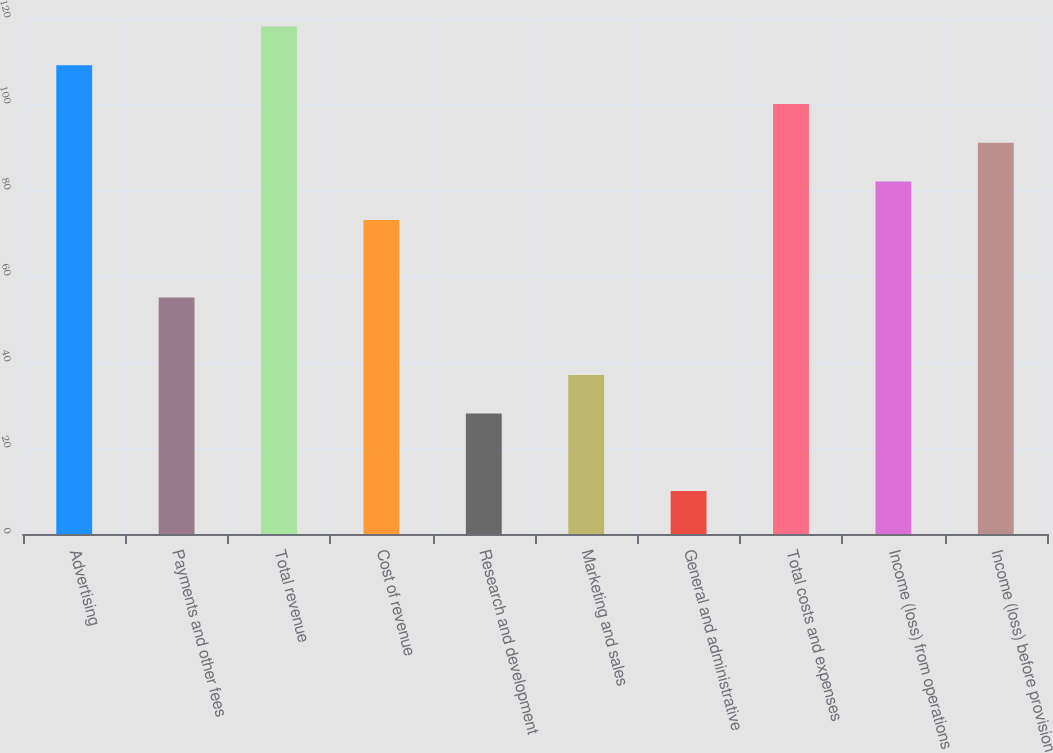<chart> <loc_0><loc_0><loc_500><loc_500><bar_chart><fcel>Advertising<fcel>Payments and other fees<fcel>Total revenue<fcel>Cost of revenue<fcel>Research and development<fcel>Marketing and sales<fcel>General and administrative<fcel>Total costs and expenses<fcel>Income (loss) from operations<fcel>Income (loss) before provision<nl><fcel>109<fcel>55<fcel>118<fcel>73<fcel>28<fcel>37<fcel>10<fcel>100<fcel>82<fcel>91<nl></chart> 